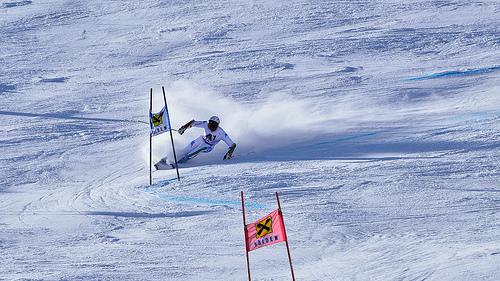Question: where was the picture taken?
Choices:
A. In the rain.
B. In the snow.
C. In the wind.
D. In the sunshine.
Answer with the letter. Answer: B Question: who is wearing white?
Choices:
A. A snowboarder.
B. A bride.
C. A skateboarder.
D. A spectator.
Answer with the letter. Answer: A Question: what is pink?
Choices:
A. A surfboard.
B. A frisbee.
C. A bandana.
D. A sign.
Answer with the letter. Answer: D Question: what is white?
Choices:
A. Shirt.
B. Shorts.
C. Boat.
D. Helmet.
Answer with the letter. Answer: D Question: where are tracks?
Choices:
A. In the sand.
B. In the grass.
C. On the snow.
D. In the mud.
Answer with the letter. Answer: C 